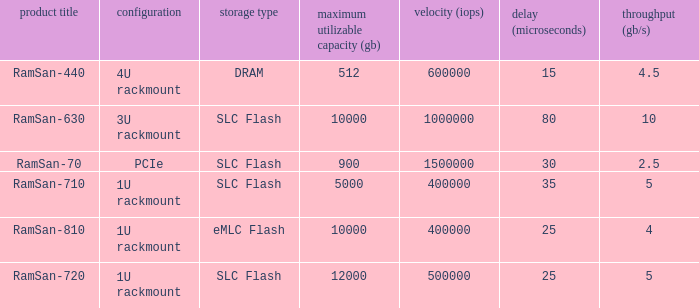What is the Input/output operations per second for the emlc flash? 400000.0. 